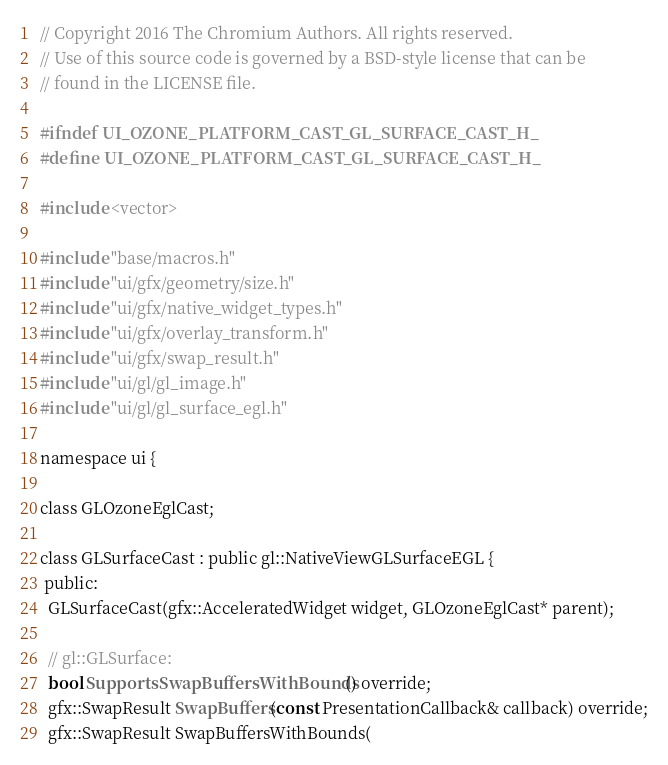Convert code to text. <code><loc_0><loc_0><loc_500><loc_500><_C_>// Copyright 2016 The Chromium Authors. All rights reserved.
// Use of this source code is governed by a BSD-style license that can be
// found in the LICENSE file.

#ifndef UI_OZONE_PLATFORM_CAST_GL_SURFACE_CAST_H_
#define UI_OZONE_PLATFORM_CAST_GL_SURFACE_CAST_H_

#include <vector>

#include "base/macros.h"
#include "ui/gfx/geometry/size.h"
#include "ui/gfx/native_widget_types.h"
#include "ui/gfx/overlay_transform.h"
#include "ui/gfx/swap_result.h"
#include "ui/gl/gl_image.h"
#include "ui/gl/gl_surface_egl.h"

namespace ui {

class GLOzoneEglCast;

class GLSurfaceCast : public gl::NativeViewGLSurfaceEGL {
 public:
  GLSurfaceCast(gfx::AcceleratedWidget widget, GLOzoneEglCast* parent);

  // gl::GLSurface:
  bool SupportsSwapBuffersWithBounds() override;
  gfx::SwapResult SwapBuffers(const PresentationCallback& callback) override;
  gfx::SwapResult SwapBuffersWithBounds(</code> 